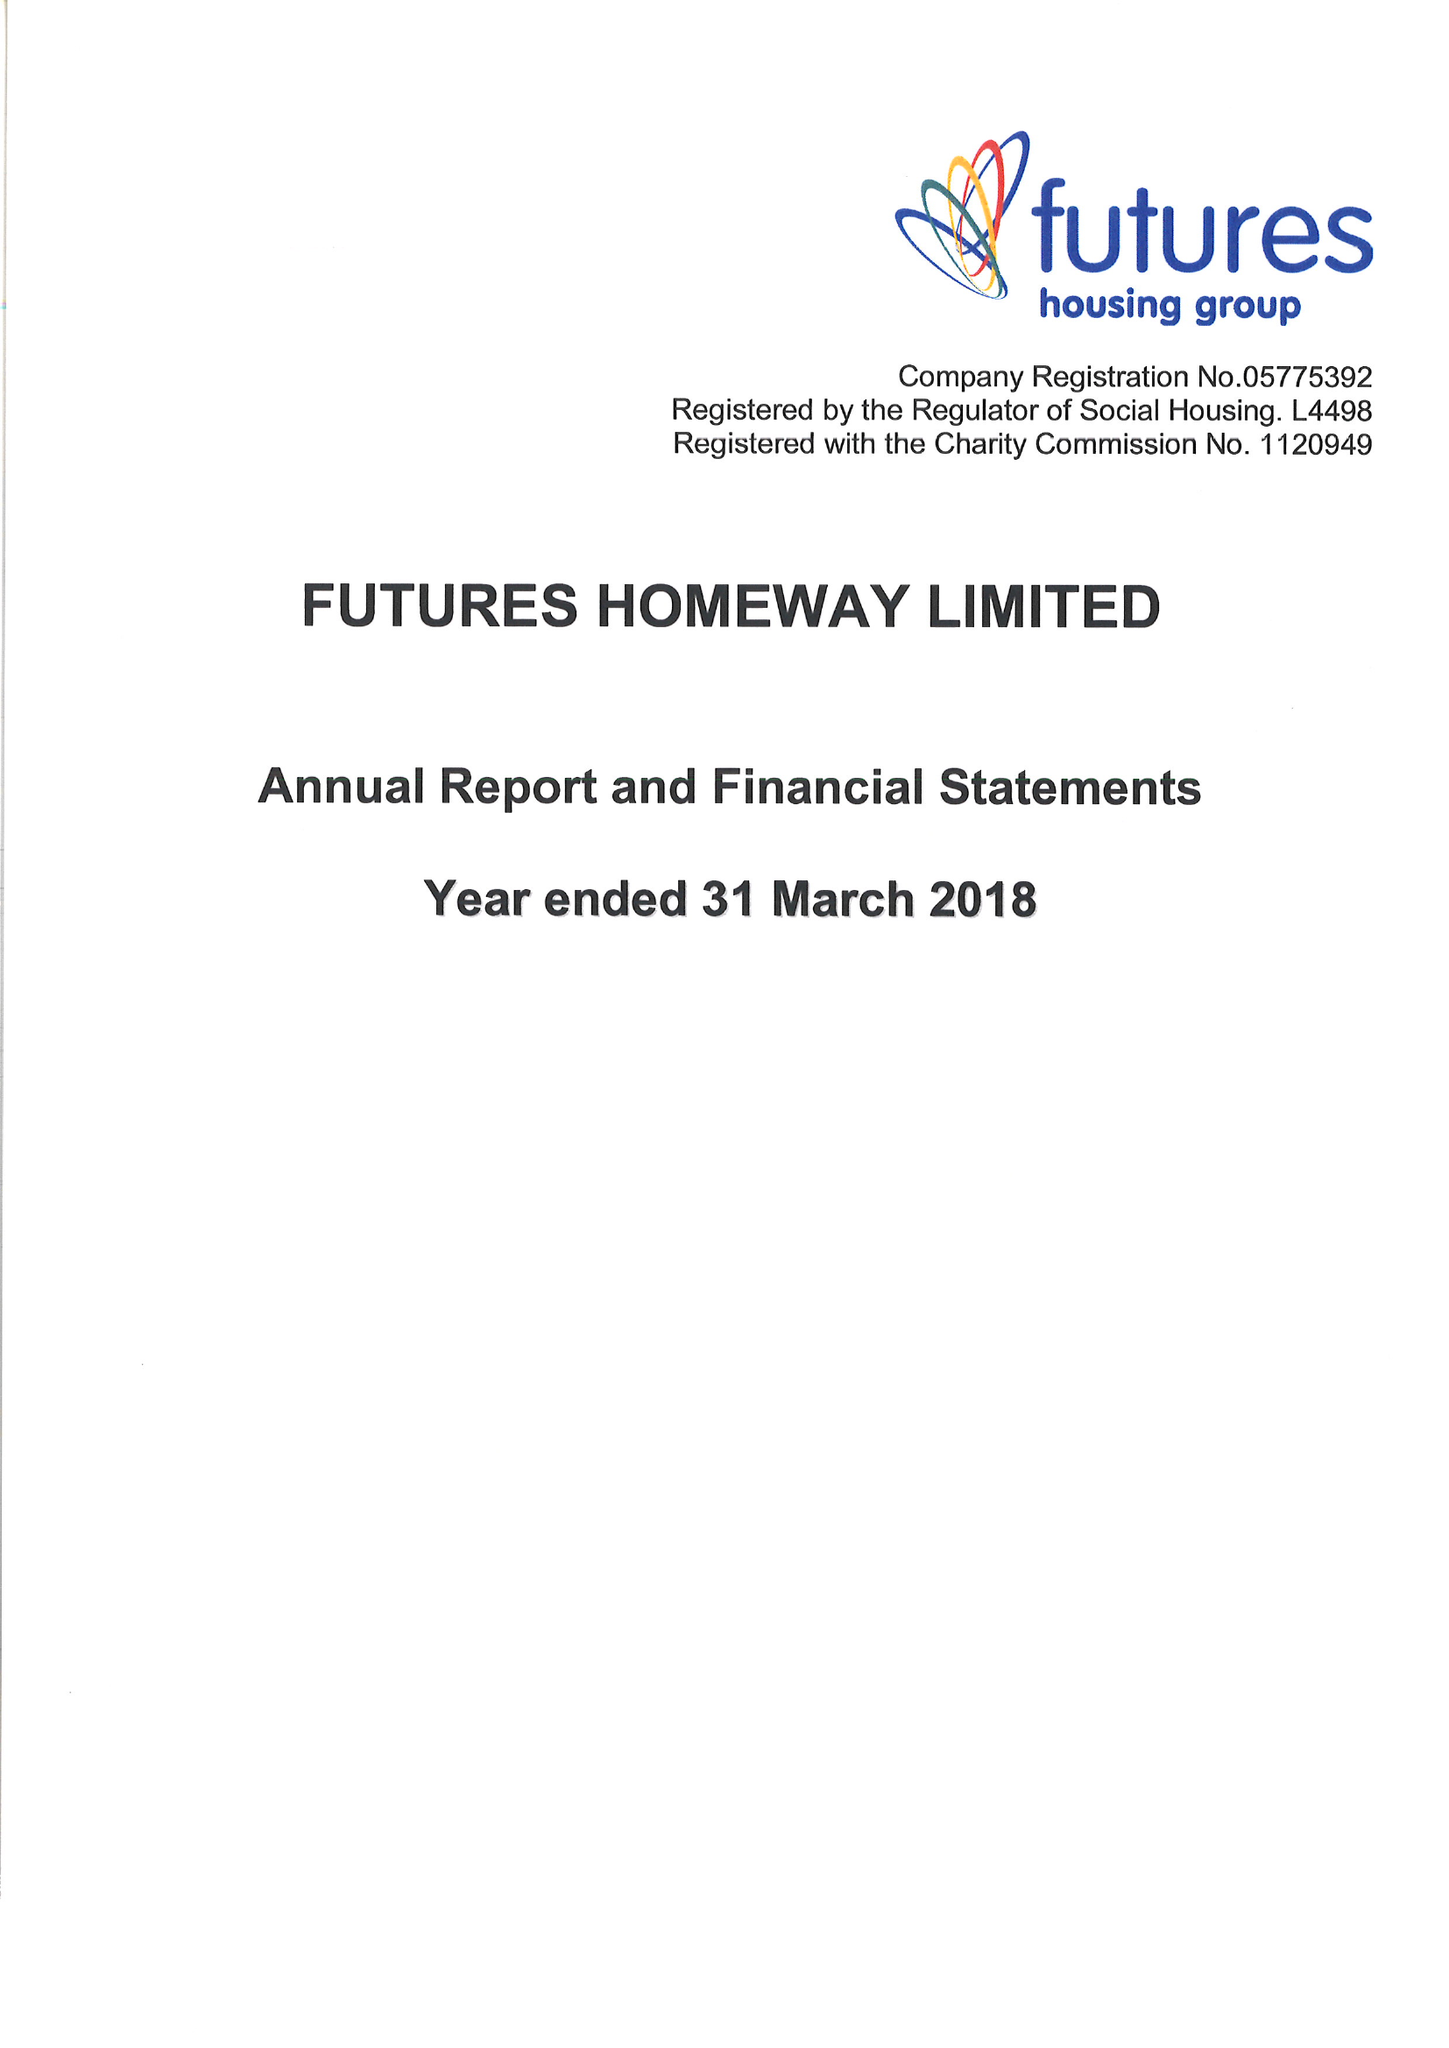What is the value for the income_annually_in_british_pounds?
Answer the question using a single word or phrase. 16390000.00 